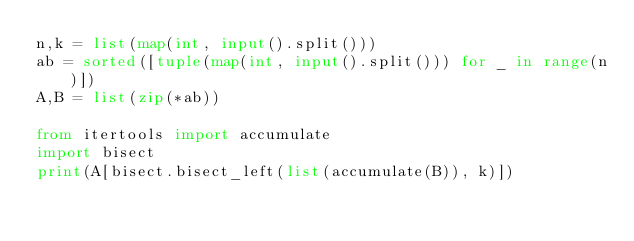<code> <loc_0><loc_0><loc_500><loc_500><_Python_>n,k = list(map(int, input().split()))
ab = sorted([tuple(map(int, input().split())) for _ in range(n)])
A,B = list(zip(*ab))

from itertools import accumulate
import bisect
print(A[bisect.bisect_left(list(accumulate(B)), k)])
</code> 